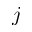<formula> <loc_0><loc_0><loc_500><loc_500>j</formula> 